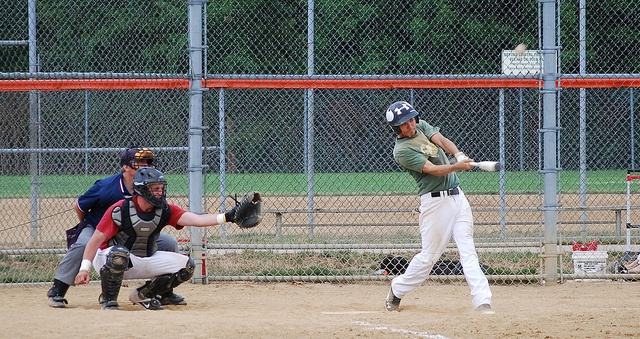Describe the objects in this image and their specific colors. I can see people in teal, lavender, darkgray, gray, and black tones, people in teal, black, gray, darkgray, and lavender tones, bench in teal, darkgray, tan, and gray tones, people in teal, black, gray, navy, and darkgray tones, and baseball glove in teal, black, gray, and darkgray tones in this image. 